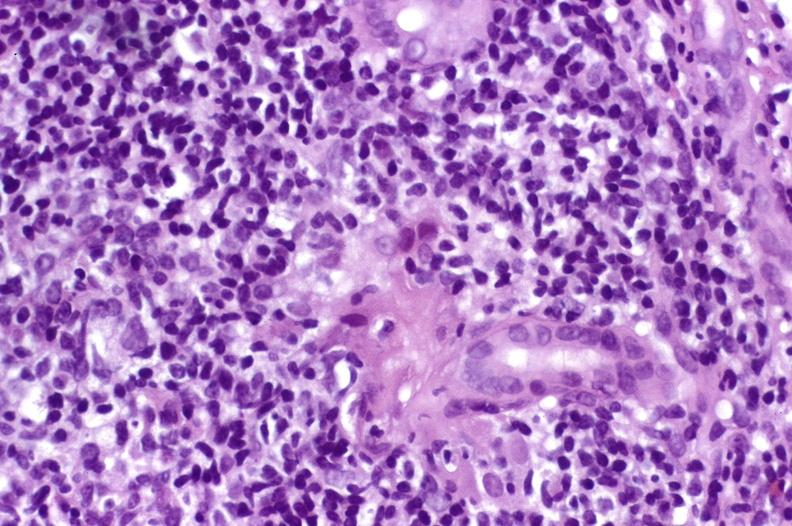what does this image show?
Answer the question using a single word or phrase. Recurrent hepatitis c virus 